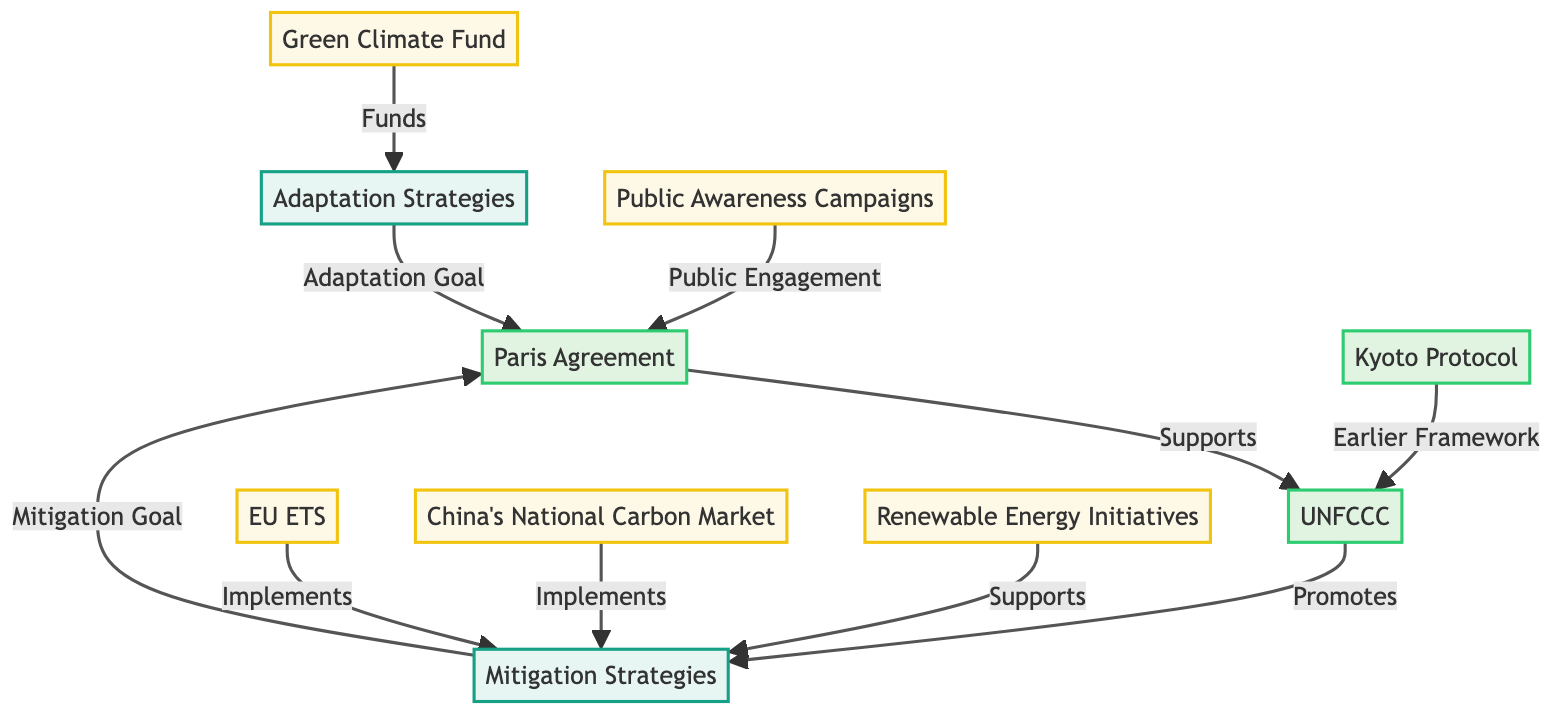What is the first policy listed in the diagram? The first policy node in the diagram is labeled 'Paris Agreement'. It is the topmost element under the 'policy' class, indicating it has a prominent position in the comparative analysis.
Answer: Paris Agreement How many initiatives are present in the diagram? By counting the nodes categorized as 'initiative', there are five distinctly labeled initiatives: Green Climate Fund, EU ETS, China's National Carbon Market, Public Awareness Campaigns, and Renewable Energy Initiatives.
Answer: 5 What does the Kyoto Protocol support? In the diagram, the Kyoto Protocol connects to the UNFCCC node with the label 'Earlier Framework', which signifies that it supports the framework established by the UNFCCC.
Answer: UNFCCC Which policy promotes mitigation strategies? The UNFCCC policy is directly linked to the mitigation strategies node with the label 'Promotes', indicating its role in advocating for strategies aimed at mitigating ice melt.
Answer: UNFCCC What type of strategies are connected to adaptation goals? The diagram shows that adaptation strategies are linked to the Paris Agreement with the label 'Adaptation Goal', indicating that these strategies are primarily aimed at achieving adaptation objectives.
Answer: Adaptation Strategies How many links support the Paris Agreement? The Paris Agreement node has three distinct connections: it is supported by the UNFCCC, receives adaptation strategies, and engages public awareness campaigns. Therefore, there are three supporting links overall.
Answer: 3 What do renewable energy initiatives support? Renewable energy initiatives are indicated to support the mitigation strategies, which suggests that these initiatives contribute to the broader goal of reducing ice melt impacts through cleaner energy sources.
Answer: Mitigation Strategies Which two initiatives implement mitigation strategies? The diagram shows that both the EU ETS and China's National Carbon Market are linked to the mitigation strategies with the label 'Implements', suggesting that these initiatives actively carry out the mitigation efforts.
Answer: EU ETS and China's National Carbon Market Which initiative funds adaptation strategies? The Green Climate Fund is directly linked to adaptation strategies with the label 'Funds', indicating its financial role in supporting adaptation measures in response to climate change.
Answer: Green Climate Fund 